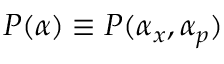Convert formula to latex. <formula><loc_0><loc_0><loc_500><loc_500>P ( \alpha ) \equiv P ( \alpha _ { x } , \alpha _ { p } )</formula> 